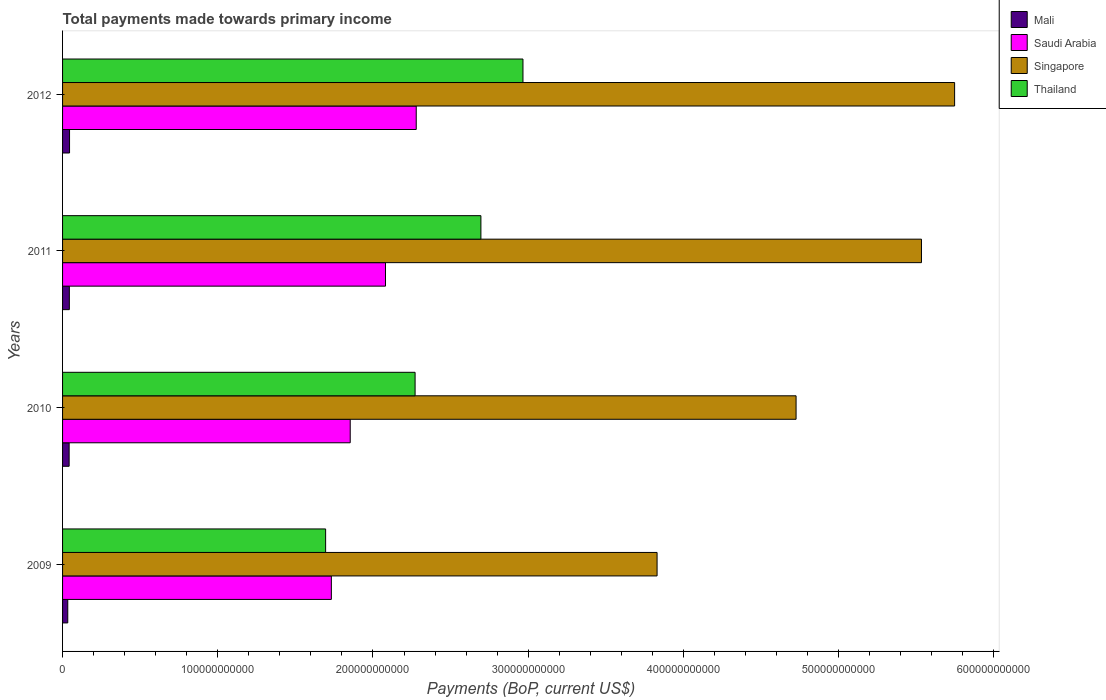How many different coloured bars are there?
Provide a succinct answer. 4. How many groups of bars are there?
Keep it short and to the point. 4. Are the number of bars per tick equal to the number of legend labels?
Make the answer very short. Yes. Are the number of bars on each tick of the Y-axis equal?
Provide a short and direct response. Yes. What is the total payments made towards primary income in Thailand in 2012?
Your answer should be very brief. 2.97e+11. Across all years, what is the maximum total payments made towards primary income in Singapore?
Offer a very short reply. 5.75e+11. Across all years, what is the minimum total payments made towards primary income in Thailand?
Your answer should be compact. 1.69e+11. What is the total total payments made towards primary income in Thailand in the graph?
Provide a short and direct response. 9.63e+11. What is the difference between the total payments made towards primary income in Singapore in 2009 and that in 2012?
Give a very brief answer. -1.92e+11. What is the difference between the total payments made towards primary income in Thailand in 2010 and the total payments made towards primary income in Mali in 2009?
Make the answer very short. 2.24e+11. What is the average total payments made towards primary income in Singapore per year?
Your answer should be very brief. 4.96e+11. In the year 2011, what is the difference between the total payments made towards primary income in Thailand and total payments made towards primary income in Singapore?
Make the answer very short. -2.84e+11. What is the ratio of the total payments made towards primary income in Saudi Arabia in 2010 to that in 2012?
Offer a very short reply. 0.81. What is the difference between the highest and the second highest total payments made towards primary income in Singapore?
Make the answer very short. 2.13e+1. What is the difference between the highest and the lowest total payments made towards primary income in Saudi Arabia?
Offer a very short reply. 5.47e+1. In how many years, is the total payments made towards primary income in Saudi Arabia greater than the average total payments made towards primary income in Saudi Arabia taken over all years?
Provide a succinct answer. 2. Is it the case that in every year, the sum of the total payments made towards primary income in Thailand and total payments made towards primary income in Saudi Arabia is greater than the sum of total payments made towards primary income in Mali and total payments made towards primary income in Singapore?
Ensure brevity in your answer.  No. What does the 1st bar from the top in 2010 represents?
Provide a succinct answer. Thailand. What does the 1st bar from the bottom in 2010 represents?
Your response must be concise. Mali. What is the difference between two consecutive major ticks on the X-axis?
Make the answer very short. 1.00e+11. Are the values on the major ticks of X-axis written in scientific E-notation?
Offer a terse response. No. Where does the legend appear in the graph?
Give a very brief answer. Top right. How are the legend labels stacked?
Ensure brevity in your answer.  Vertical. What is the title of the graph?
Give a very brief answer. Total payments made towards primary income. Does "Belgium" appear as one of the legend labels in the graph?
Give a very brief answer. No. What is the label or title of the X-axis?
Provide a succinct answer. Payments (BoP, current US$). What is the label or title of the Y-axis?
Offer a very short reply. Years. What is the Payments (BoP, current US$) in Mali in 2009?
Your answer should be very brief. 3.35e+09. What is the Payments (BoP, current US$) of Saudi Arabia in 2009?
Offer a terse response. 1.73e+11. What is the Payments (BoP, current US$) of Singapore in 2009?
Make the answer very short. 3.83e+11. What is the Payments (BoP, current US$) of Thailand in 2009?
Ensure brevity in your answer.  1.69e+11. What is the Payments (BoP, current US$) in Mali in 2010?
Offer a very short reply. 4.24e+09. What is the Payments (BoP, current US$) of Saudi Arabia in 2010?
Offer a terse response. 1.85e+11. What is the Payments (BoP, current US$) of Singapore in 2010?
Offer a terse response. 4.73e+11. What is the Payments (BoP, current US$) of Thailand in 2010?
Ensure brevity in your answer.  2.27e+11. What is the Payments (BoP, current US$) in Mali in 2011?
Make the answer very short. 4.37e+09. What is the Payments (BoP, current US$) of Saudi Arabia in 2011?
Give a very brief answer. 2.08e+11. What is the Payments (BoP, current US$) in Singapore in 2011?
Provide a succinct answer. 5.53e+11. What is the Payments (BoP, current US$) of Thailand in 2011?
Give a very brief answer. 2.70e+11. What is the Payments (BoP, current US$) of Mali in 2012?
Your response must be concise. 4.49e+09. What is the Payments (BoP, current US$) in Saudi Arabia in 2012?
Make the answer very short. 2.28e+11. What is the Payments (BoP, current US$) of Singapore in 2012?
Keep it short and to the point. 5.75e+11. What is the Payments (BoP, current US$) in Thailand in 2012?
Make the answer very short. 2.97e+11. Across all years, what is the maximum Payments (BoP, current US$) of Mali?
Offer a terse response. 4.49e+09. Across all years, what is the maximum Payments (BoP, current US$) in Saudi Arabia?
Provide a short and direct response. 2.28e+11. Across all years, what is the maximum Payments (BoP, current US$) in Singapore?
Give a very brief answer. 5.75e+11. Across all years, what is the maximum Payments (BoP, current US$) of Thailand?
Keep it short and to the point. 2.97e+11. Across all years, what is the minimum Payments (BoP, current US$) of Mali?
Provide a succinct answer. 3.35e+09. Across all years, what is the minimum Payments (BoP, current US$) in Saudi Arabia?
Your answer should be very brief. 1.73e+11. Across all years, what is the minimum Payments (BoP, current US$) of Singapore?
Offer a terse response. 3.83e+11. Across all years, what is the minimum Payments (BoP, current US$) in Thailand?
Keep it short and to the point. 1.69e+11. What is the total Payments (BoP, current US$) of Mali in the graph?
Provide a succinct answer. 1.65e+1. What is the total Payments (BoP, current US$) in Saudi Arabia in the graph?
Provide a short and direct response. 7.94e+11. What is the total Payments (BoP, current US$) in Singapore in the graph?
Your answer should be very brief. 1.98e+12. What is the total Payments (BoP, current US$) of Thailand in the graph?
Offer a terse response. 9.63e+11. What is the difference between the Payments (BoP, current US$) in Mali in 2009 and that in 2010?
Your answer should be very brief. -8.85e+08. What is the difference between the Payments (BoP, current US$) in Saudi Arabia in 2009 and that in 2010?
Make the answer very short. -1.21e+1. What is the difference between the Payments (BoP, current US$) in Singapore in 2009 and that in 2010?
Your answer should be very brief. -8.96e+1. What is the difference between the Payments (BoP, current US$) of Thailand in 2009 and that in 2010?
Make the answer very short. -5.76e+1. What is the difference between the Payments (BoP, current US$) in Mali in 2009 and that in 2011?
Offer a terse response. -1.02e+09. What is the difference between the Payments (BoP, current US$) in Saudi Arabia in 2009 and that in 2011?
Provide a succinct answer. -3.49e+1. What is the difference between the Payments (BoP, current US$) of Singapore in 2009 and that in 2011?
Give a very brief answer. -1.70e+11. What is the difference between the Payments (BoP, current US$) of Thailand in 2009 and that in 2011?
Your answer should be very brief. -1.00e+11. What is the difference between the Payments (BoP, current US$) of Mali in 2009 and that in 2012?
Offer a very short reply. -1.14e+09. What is the difference between the Payments (BoP, current US$) of Saudi Arabia in 2009 and that in 2012?
Your response must be concise. -5.47e+1. What is the difference between the Payments (BoP, current US$) of Singapore in 2009 and that in 2012?
Your response must be concise. -1.92e+11. What is the difference between the Payments (BoP, current US$) of Thailand in 2009 and that in 2012?
Provide a succinct answer. -1.27e+11. What is the difference between the Payments (BoP, current US$) of Mali in 2010 and that in 2011?
Offer a very short reply. -1.36e+08. What is the difference between the Payments (BoP, current US$) of Saudi Arabia in 2010 and that in 2011?
Provide a succinct answer. -2.27e+1. What is the difference between the Payments (BoP, current US$) of Singapore in 2010 and that in 2011?
Give a very brief answer. -8.08e+1. What is the difference between the Payments (BoP, current US$) of Thailand in 2010 and that in 2011?
Your response must be concise. -4.24e+1. What is the difference between the Payments (BoP, current US$) of Mali in 2010 and that in 2012?
Ensure brevity in your answer.  -2.59e+08. What is the difference between the Payments (BoP, current US$) in Saudi Arabia in 2010 and that in 2012?
Give a very brief answer. -4.25e+1. What is the difference between the Payments (BoP, current US$) in Singapore in 2010 and that in 2012?
Offer a very short reply. -1.02e+11. What is the difference between the Payments (BoP, current US$) of Thailand in 2010 and that in 2012?
Offer a terse response. -6.95e+1. What is the difference between the Payments (BoP, current US$) in Mali in 2011 and that in 2012?
Offer a terse response. -1.24e+08. What is the difference between the Payments (BoP, current US$) in Saudi Arabia in 2011 and that in 2012?
Ensure brevity in your answer.  -1.98e+1. What is the difference between the Payments (BoP, current US$) of Singapore in 2011 and that in 2012?
Your answer should be compact. -2.13e+1. What is the difference between the Payments (BoP, current US$) of Thailand in 2011 and that in 2012?
Give a very brief answer. -2.71e+1. What is the difference between the Payments (BoP, current US$) in Mali in 2009 and the Payments (BoP, current US$) in Saudi Arabia in 2010?
Your answer should be compact. -1.82e+11. What is the difference between the Payments (BoP, current US$) of Mali in 2009 and the Payments (BoP, current US$) of Singapore in 2010?
Offer a terse response. -4.69e+11. What is the difference between the Payments (BoP, current US$) in Mali in 2009 and the Payments (BoP, current US$) in Thailand in 2010?
Ensure brevity in your answer.  -2.24e+11. What is the difference between the Payments (BoP, current US$) of Saudi Arabia in 2009 and the Payments (BoP, current US$) of Singapore in 2010?
Your answer should be compact. -2.99e+11. What is the difference between the Payments (BoP, current US$) in Saudi Arabia in 2009 and the Payments (BoP, current US$) in Thailand in 2010?
Give a very brief answer. -5.39e+1. What is the difference between the Payments (BoP, current US$) of Singapore in 2009 and the Payments (BoP, current US$) of Thailand in 2010?
Your answer should be compact. 1.56e+11. What is the difference between the Payments (BoP, current US$) in Mali in 2009 and the Payments (BoP, current US$) in Saudi Arabia in 2011?
Provide a succinct answer. -2.05e+11. What is the difference between the Payments (BoP, current US$) in Mali in 2009 and the Payments (BoP, current US$) in Singapore in 2011?
Make the answer very short. -5.50e+11. What is the difference between the Payments (BoP, current US$) in Mali in 2009 and the Payments (BoP, current US$) in Thailand in 2011?
Ensure brevity in your answer.  -2.66e+11. What is the difference between the Payments (BoP, current US$) in Saudi Arabia in 2009 and the Payments (BoP, current US$) in Singapore in 2011?
Your answer should be very brief. -3.80e+11. What is the difference between the Payments (BoP, current US$) of Saudi Arabia in 2009 and the Payments (BoP, current US$) of Thailand in 2011?
Your answer should be compact. -9.64e+1. What is the difference between the Payments (BoP, current US$) in Singapore in 2009 and the Payments (BoP, current US$) in Thailand in 2011?
Your response must be concise. 1.13e+11. What is the difference between the Payments (BoP, current US$) of Mali in 2009 and the Payments (BoP, current US$) of Saudi Arabia in 2012?
Ensure brevity in your answer.  -2.25e+11. What is the difference between the Payments (BoP, current US$) of Mali in 2009 and the Payments (BoP, current US$) of Singapore in 2012?
Your response must be concise. -5.71e+11. What is the difference between the Payments (BoP, current US$) in Mali in 2009 and the Payments (BoP, current US$) in Thailand in 2012?
Your answer should be very brief. -2.93e+11. What is the difference between the Payments (BoP, current US$) of Saudi Arabia in 2009 and the Payments (BoP, current US$) of Singapore in 2012?
Provide a succinct answer. -4.02e+11. What is the difference between the Payments (BoP, current US$) of Saudi Arabia in 2009 and the Payments (BoP, current US$) of Thailand in 2012?
Your answer should be very brief. -1.23e+11. What is the difference between the Payments (BoP, current US$) in Singapore in 2009 and the Payments (BoP, current US$) in Thailand in 2012?
Offer a terse response. 8.64e+1. What is the difference between the Payments (BoP, current US$) of Mali in 2010 and the Payments (BoP, current US$) of Saudi Arabia in 2011?
Your answer should be compact. -2.04e+11. What is the difference between the Payments (BoP, current US$) in Mali in 2010 and the Payments (BoP, current US$) in Singapore in 2011?
Give a very brief answer. -5.49e+11. What is the difference between the Payments (BoP, current US$) of Mali in 2010 and the Payments (BoP, current US$) of Thailand in 2011?
Make the answer very short. -2.65e+11. What is the difference between the Payments (BoP, current US$) in Saudi Arabia in 2010 and the Payments (BoP, current US$) in Singapore in 2011?
Give a very brief answer. -3.68e+11. What is the difference between the Payments (BoP, current US$) in Saudi Arabia in 2010 and the Payments (BoP, current US$) in Thailand in 2011?
Keep it short and to the point. -8.42e+1. What is the difference between the Payments (BoP, current US$) in Singapore in 2010 and the Payments (BoP, current US$) in Thailand in 2011?
Keep it short and to the point. 2.03e+11. What is the difference between the Payments (BoP, current US$) of Mali in 2010 and the Payments (BoP, current US$) of Saudi Arabia in 2012?
Make the answer very short. -2.24e+11. What is the difference between the Payments (BoP, current US$) in Mali in 2010 and the Payments (BoP, current US$) in Singapore in 2012?
Offer a very short reply. -5.70e+11. What is the difference between the Payments (BoP, current US$) in Mali in 2010 and the Payments (BoP, current US$) in Thailand in 2012?
Offer a terse response. -2.92e+11. What is the difference between the Payments (BoP, current US$) in Saudi Arabia in 2010 and the Payments (BoP, current US$) in Singapore in 2012?
Offer a terse response. -3.89e+11. What is the difference between the Payments (BoP, current US$) in Saudi Arabia in 2010 and the Payments (BoP, current US$) in Thailand in 2012?
Your answer should be very brief. -1.11e+11. What is the difference between the Payments (BoP, current US$) of Singapore in 2010 and the Payments (BoP, current US$) of Thailand in 2012?
Keep it short and to the point. 1.76e+11. What is the difference between the Payments (BoP, current US$) of Mali in 2011 and the Payments (BoP, current US$) of Saudi Arabia in 2012?
Make the answer very short. -2.23e+11. What is the difference between the Payments (BoP, current US$) of Mali in 2011 and the Payments (BoP, current US$) of Singapore in 2012?
Your answer should be very brief. -5.70e+11. What is the difference between the Payments (BoP, current US$) of Mali in 2011 and the Payments (BoP, current US$) of Thailand in 2012?
Provide a succinct answer. -2.92e+11. What is the difference between the Payments (BoP, current US$) in Saudi Arabia in 2011 and the Payments (BoP, current US$) in Singapore in 2012?
Give a very brief answer. -3.67e+11. What is the difference between the Payments (BoP, current US$) in Saudi Arabia in 2011 and the Payments (BoP, current US$) in Thailand in 2012?
Give a very brief answer. -8.86e+1. What is the difference between the Payments (BoP, current US$) in Singapore in 2011 and the Payments (BoP, current US$) in Thailand in 2012?
Provide a short and direct response. 2.57e+11. What is the average Payments (BoP, current US$) of Mali per year?
Ensure brevity in your answer.  4.11e+09. What is the average Payments (BoP, current US$) in Saudi Arabia per year?
Offer a terse response. 1.99e+11. What is the average Payments (BoP, current US$) in Singapore per year?
Ensure brevity in your answer.  4.96e+11. What is the average Payments (BoP, current US$) in Thailand per year?
Provide a succinct answer. 2.41e+11. In the year 2009, what is the difference between the Payments (BoP, current US$) of Mali and Payments (BoP, current US$) of Saudi Arabia?
Make the answer very short. -1.70e+11. In the year 2009, what is the difference between the Payments (BoP, current US$) in Mali and Payments (BoP, current US$) in Singapore?
Your response must be concise. -3.80e+11. In the year 2009, what is the difference between the Payments (BoP, current US$) of Mali and Payments (BoP, current US$) of Thailand?
Ensure brevity in your answer.  -1.66e+11. In the year 2009, what is the difference between the Payments (BoP, current US$) in Saudi Arabia and Payments (BoP, current US$) in Singapore?
Your response must be concise. -2.10e+11. In the year 2009, what is the difference between the Payments (BoP, current US$) of Saudi Arabia and Payments (BoP, current US$) of Thailand?
Provide a short and direct response. 3.70e+09. In the year 2009, what is the difference between the Payments (BoP, current US$) of Singapore and Payments (BoP, current US$) of Thailand?
Ensure brevity in your answer.  2.14e+11. In the year 2010, what is the difference between the Payments (BoP, current US$) in Mali and Payments (BoP, current US$) in Saudi Arabia?
Provide a succinct answer. -1.81e+11. In the year 2010, what is the difference between the Payments (BoP, current US$) of Mali and Payments (BoP, current US$) of Singapore?
Your answer should be compact. -4.68e+11. In the year 2010, what is the difference between the Payments (BoP, current US$) in Mali and Payments (BoP, current US$) in Thailand?
Your answer should be compact. -2.23e+11. In the year 2010, what is the difference between the Payments (BoP, current US$) in Saudi Arabia and Payments (BoP, current US$) in Singapore?
Your answer should be compact. -2.87e+11. In the year 2010, what is the difference between the Payments (BoP, current US$) of Saudi Arabia and Payments (BoP, current US$) of Thailand?
Ensure brevity in your answer.  -4.18e+1. In the year 2010, what is the difference between the Payments (BoP, current US$) of Singapore and Payments (BoP, current US$) of Thailand?
Provide a succinct answer. 2.45e+11. In the year 2011, what is the difference between the Payments (BoP, current US$) of Mali and Payments (BoP, current US$) of Saudi Arabia?
Your answer should be very brief. -2.04e+11. In the year 2011, what is the difference between the Payments (BoP, current US$) in Mali and Payments (BoP, current US$) in Singapore?
Provide a short and direct response. -5.49e+11. In the year 2011, what is the difference between the Payments (BoP, current US$) in Mali and Payments (BoP, current US$) in Thailand?
Give a very brief answer. -2.65e+11. In the year 2011, what is the difference between the Payments (BoP, current US$) in Saudi Arabia and Payments (BoP, current US$) in Singapore?
Provide a short and direct response. -3.45e+11. In the year 2011, what is the difference between the Payments (BoP, current US$) in Saudi Arabia and Payments (BoP, current US$) in Thailand?
Make the answer very short. -6.15e+1. In the year 2011, what is the difference between the Payments (BoP, current US$) in Singapore and Payments (BoP, current US$) in Thailand?
Your response must be concise. 2.84e+11. In the year 2012, what is the difference between the Payments (BoP, current US$) in Mali and Payments (BoP, current US$) in Saudi Arabia?
Your response must be concise. -2.23e+11. In the year 2012, what is the difference between the Payments (BoP, current US$) of Mali and Payments (BoP, current US$) of Singapore?
Ensure brevity in your answer.  -5.70e+11. In the year 2012, what is the difference between the Payments (BoP, current US$) of Mali and Payments (BoP, current US$) of Thailand?
Your answer should be very brief. -2.92e+11. In the year 2012, what is the difference between the Payments (BoP, current US$) of Saudi Arabia and Payments (BoP, current US$) of Singapore?
Your answer should be compact. -3.47e+11. In the year 2012, what is the difference between the Payments (BoP, current US$) of Saudi Arabia and Payments (BoP, current US$) of Thailand?
Provide a succinct answer. -6.88e+1. In the year 2012, what is the difference between the Payments (BoP, current US$) of Singapore and Payments (BoP, current US$) of Thailand?
Offer a terse response. 2.78e+11. What is the ratio of the Payments (BoP, current US$) in Mali in 2009 to that in 2010?
Your answer should be very brief. 0.79. What is the ratio of the Payments (BoP, current US$) in Saudi Arabia in 2009 to that in 2010?
Provide a succinct answer. 0.93. What is the ratio of the Payments (BoP, current US$) in Singapore in 2009 to that in 2010?
Your answer should be very brief. 0.81. What is the ratio of the Payments (BoP, current US$) in Thailand in 2009 to that in 2010?
Offer a very short reply. 0.75. What is the ratio of the Payments (BoP, current US$) of Mali in 2009 to that in 2011?
Your response must be concise. 0.77. What is the ratio of the Payments (BoP, current US$) in Saudi Arabia in 2009 to that in 2011?
Offer a terse response. 0.83. What is the ratio of the Payments (BoP, current US$) of Singapore in 2009 to that in 2011?
Your answer should be compact. 0.69. What is the ratio of the Payments (BoP, current US$) in Thailand in 2009 to that in 2011?
Provide a succinct answer. 0.63. What is the ratio of the Payments (BoP, current US$) of Mali in 2009 to that in 2012?
Your answer should be very brief. 0.75. What is the ratio of the Payments (BoP, current US$) in Saudi Arabia in 2009 to that in 2012?
Offer a very short reply. 0.76. What is the ratio of the Payments (BoP, current US$) in Singapore in 2009 to that in 2012?
Your answer should be very brief. 0.67. What is the ratio of the Payments (BoP, current US$) of Saudi Arabia in 2010 to that in 2011?
Your answer should be compact. 0.89. What is the ratio of the Payments (BoP, current US$) in Singapore in 2010 to that in 2011?
Offer a very short reply. 0.85. What is the ratio of the Payments (BoP, current US$) in Thailand in 2010 to that in 2011?
Provide a short and direct response. 0.84. What is the ratio of the Payments (BoP, current US$) in Mali in 2010 to that in 2012?
Offer a terse response. 0.94. What is the ratio of the Payments (BoP, current US$) in Saudi Arabia in 2010 to that in 2012?
Your answer should be compact. 0.81. What is the ratio of the Payments (BoP, current US$) of Singapore in 2010 to that in 2012?
Your answer should be compact. 0.82. What is the ratio of the Payments (BoP, current US$) of Thailand in 2010 to that in 2012?
Offer a terse response. 0.77. What is the ratio of the Payments (BoP, current US$) in Mali in 2011 to that in 2012?
Ensure brevity in your answer.  0.97. What is the ratio of the Payments (BoP, current US$) in Saudi Arabia in 2011 to that in 2012?
Provide a succinct answer. 0.91. What is the ratio of the Payments (BoP, current US$) in Singapore in 2011 to that in 2012?
Keep it short and to the point. 0.96. What is the ratio of the Payments (BoP, current US$) of Thailand in 2011 to that in 2012?
Provide a succinct answer. 0.91. What is the difference between the highest and the second highest Payments (BoP, current US$) in Mali?
Your response must be concise. 1.24e+08. What is the difference between the highest and the second highest Payments (BoP, current US$) of Saudi Arabia?
Ensure brevity in your answer.  1.98e+1. What is the difference between the highest and the second highest Payments (BoP, current US$) in Singapore?
Provide a short and direct response. 2.13e+1. What is the difference between the highest and the second highest Payments (BoP, current US$) in Thailand?
Your response must be concise. 2.71e+1. What is the difference between the highest and the lowest Payments (BoP, current US$) of Mali?
Give a very brief answer. 1.14e+09. What is the difference between the highest and the lowest Payments (BoP, current US$) in Saudi Arabia?
Your response must be concise. 5.47e+1. What is the difference between the highest and the lowest Payments (BoP, current US$) of Singapore?
Offer a terse response. 1.92e+11. What is the difference between the highest and the lowest Payments (BoP, current US$) in Thailand?
Give a very brief answer. 1.27e+11. 